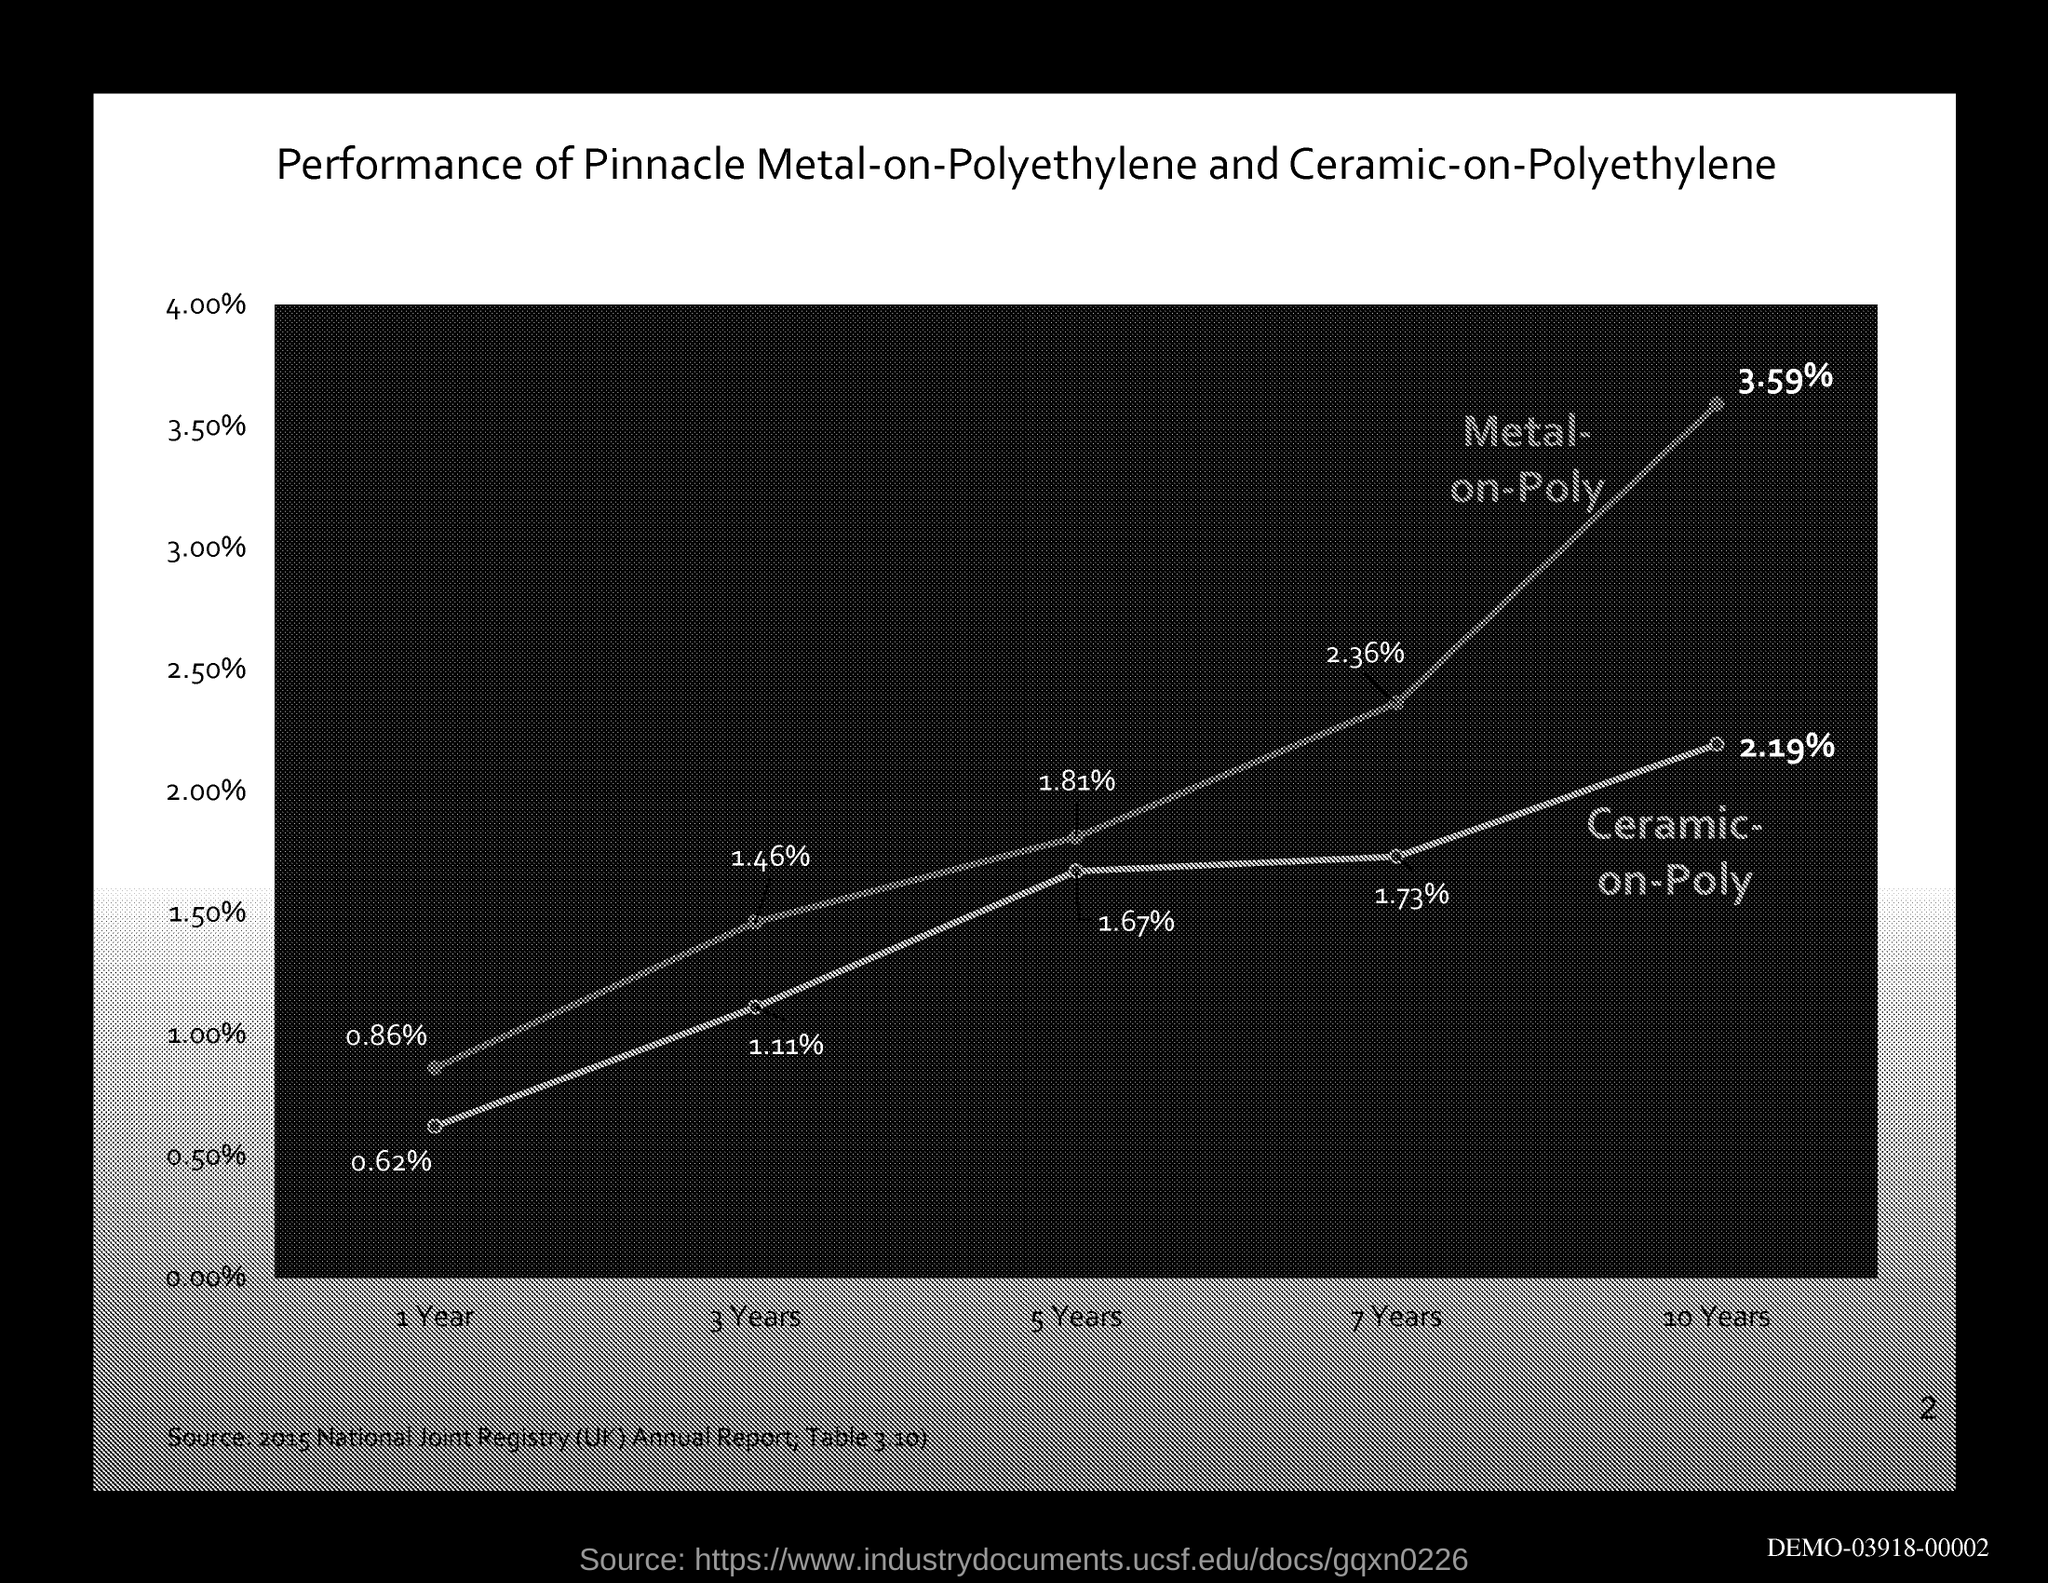What is the title of the graph?
Offer a terse response. Performance of Pinnacle Metal-on-Polyethylene and Ceramic-on-Polyethylene. 